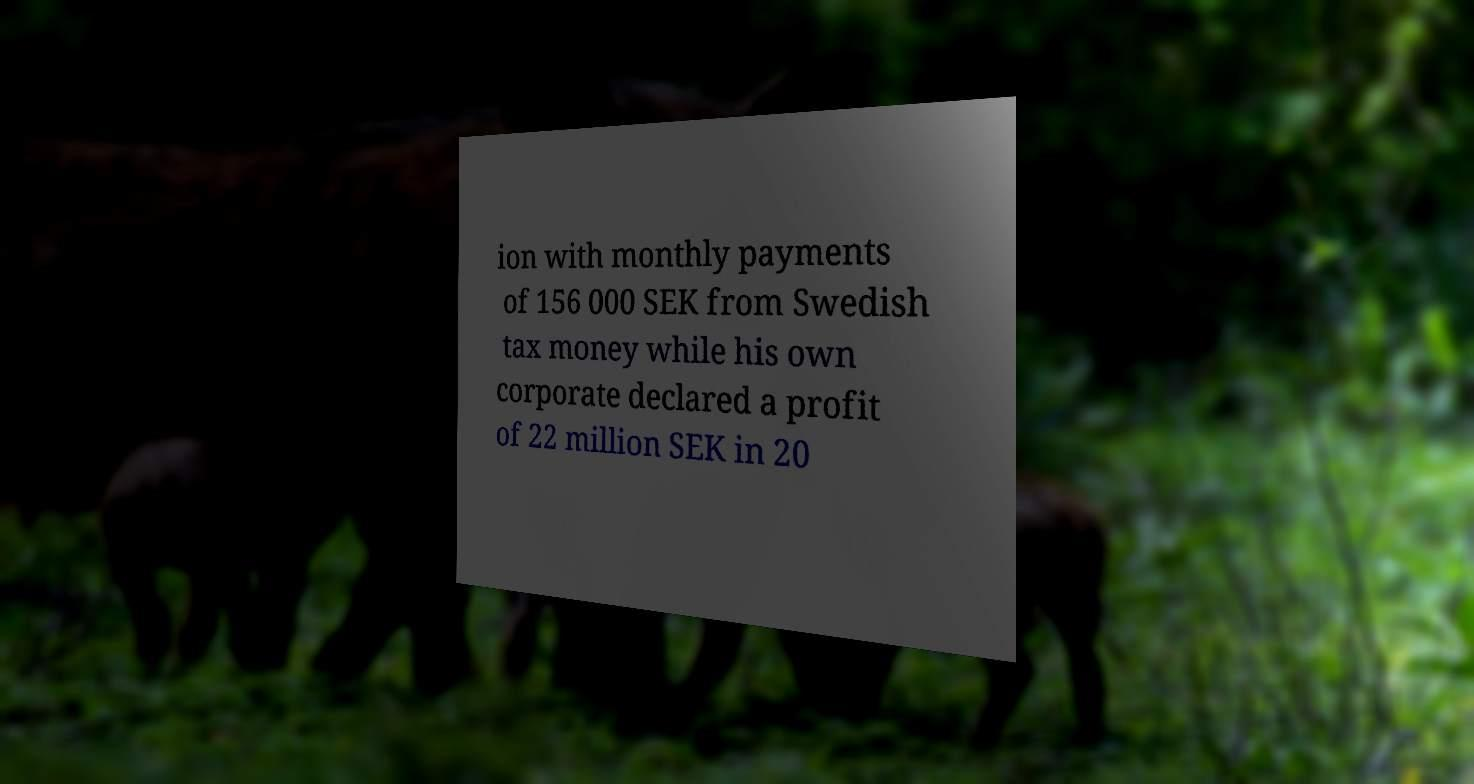For documentation purposes, I need the text within this image transcribed. Could you provide that? ion with monthly payments of 156 000 SEK from Swedish tax money while his own corporate declared a profit of 22 million SEK in 20 